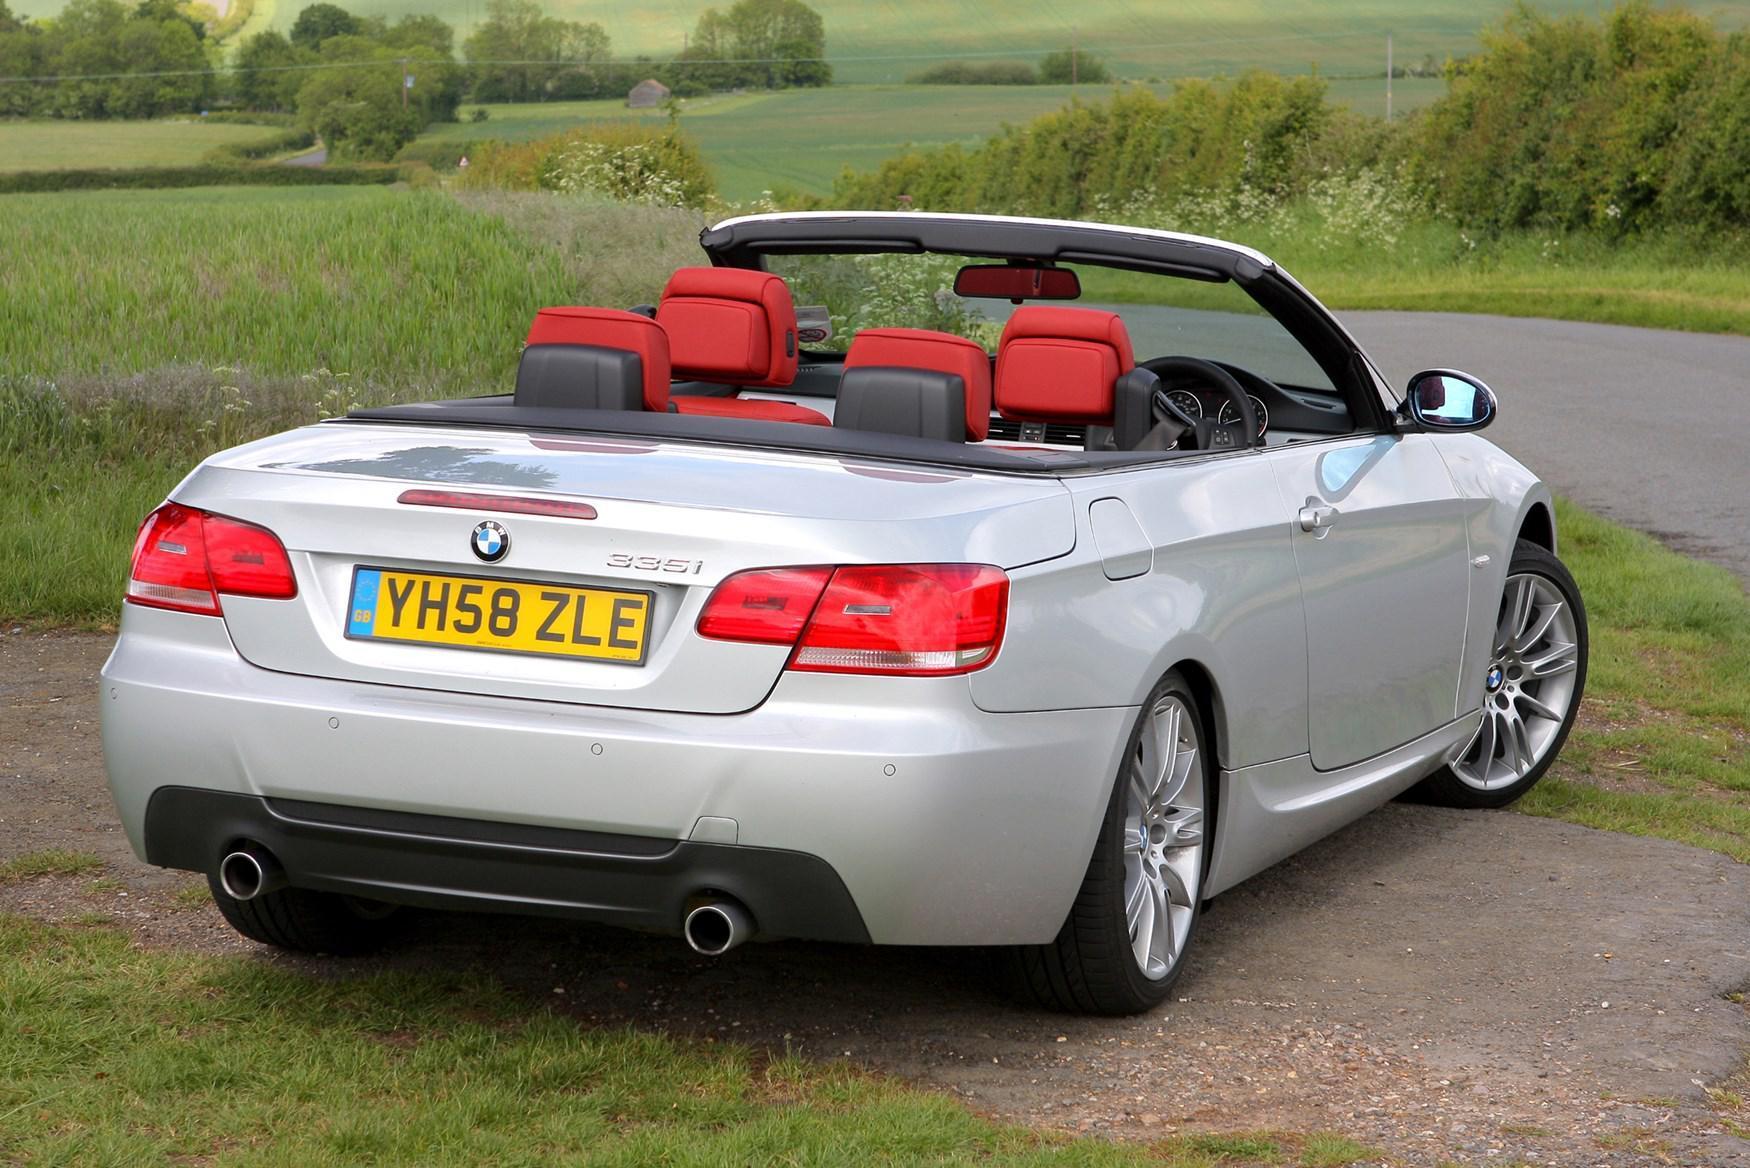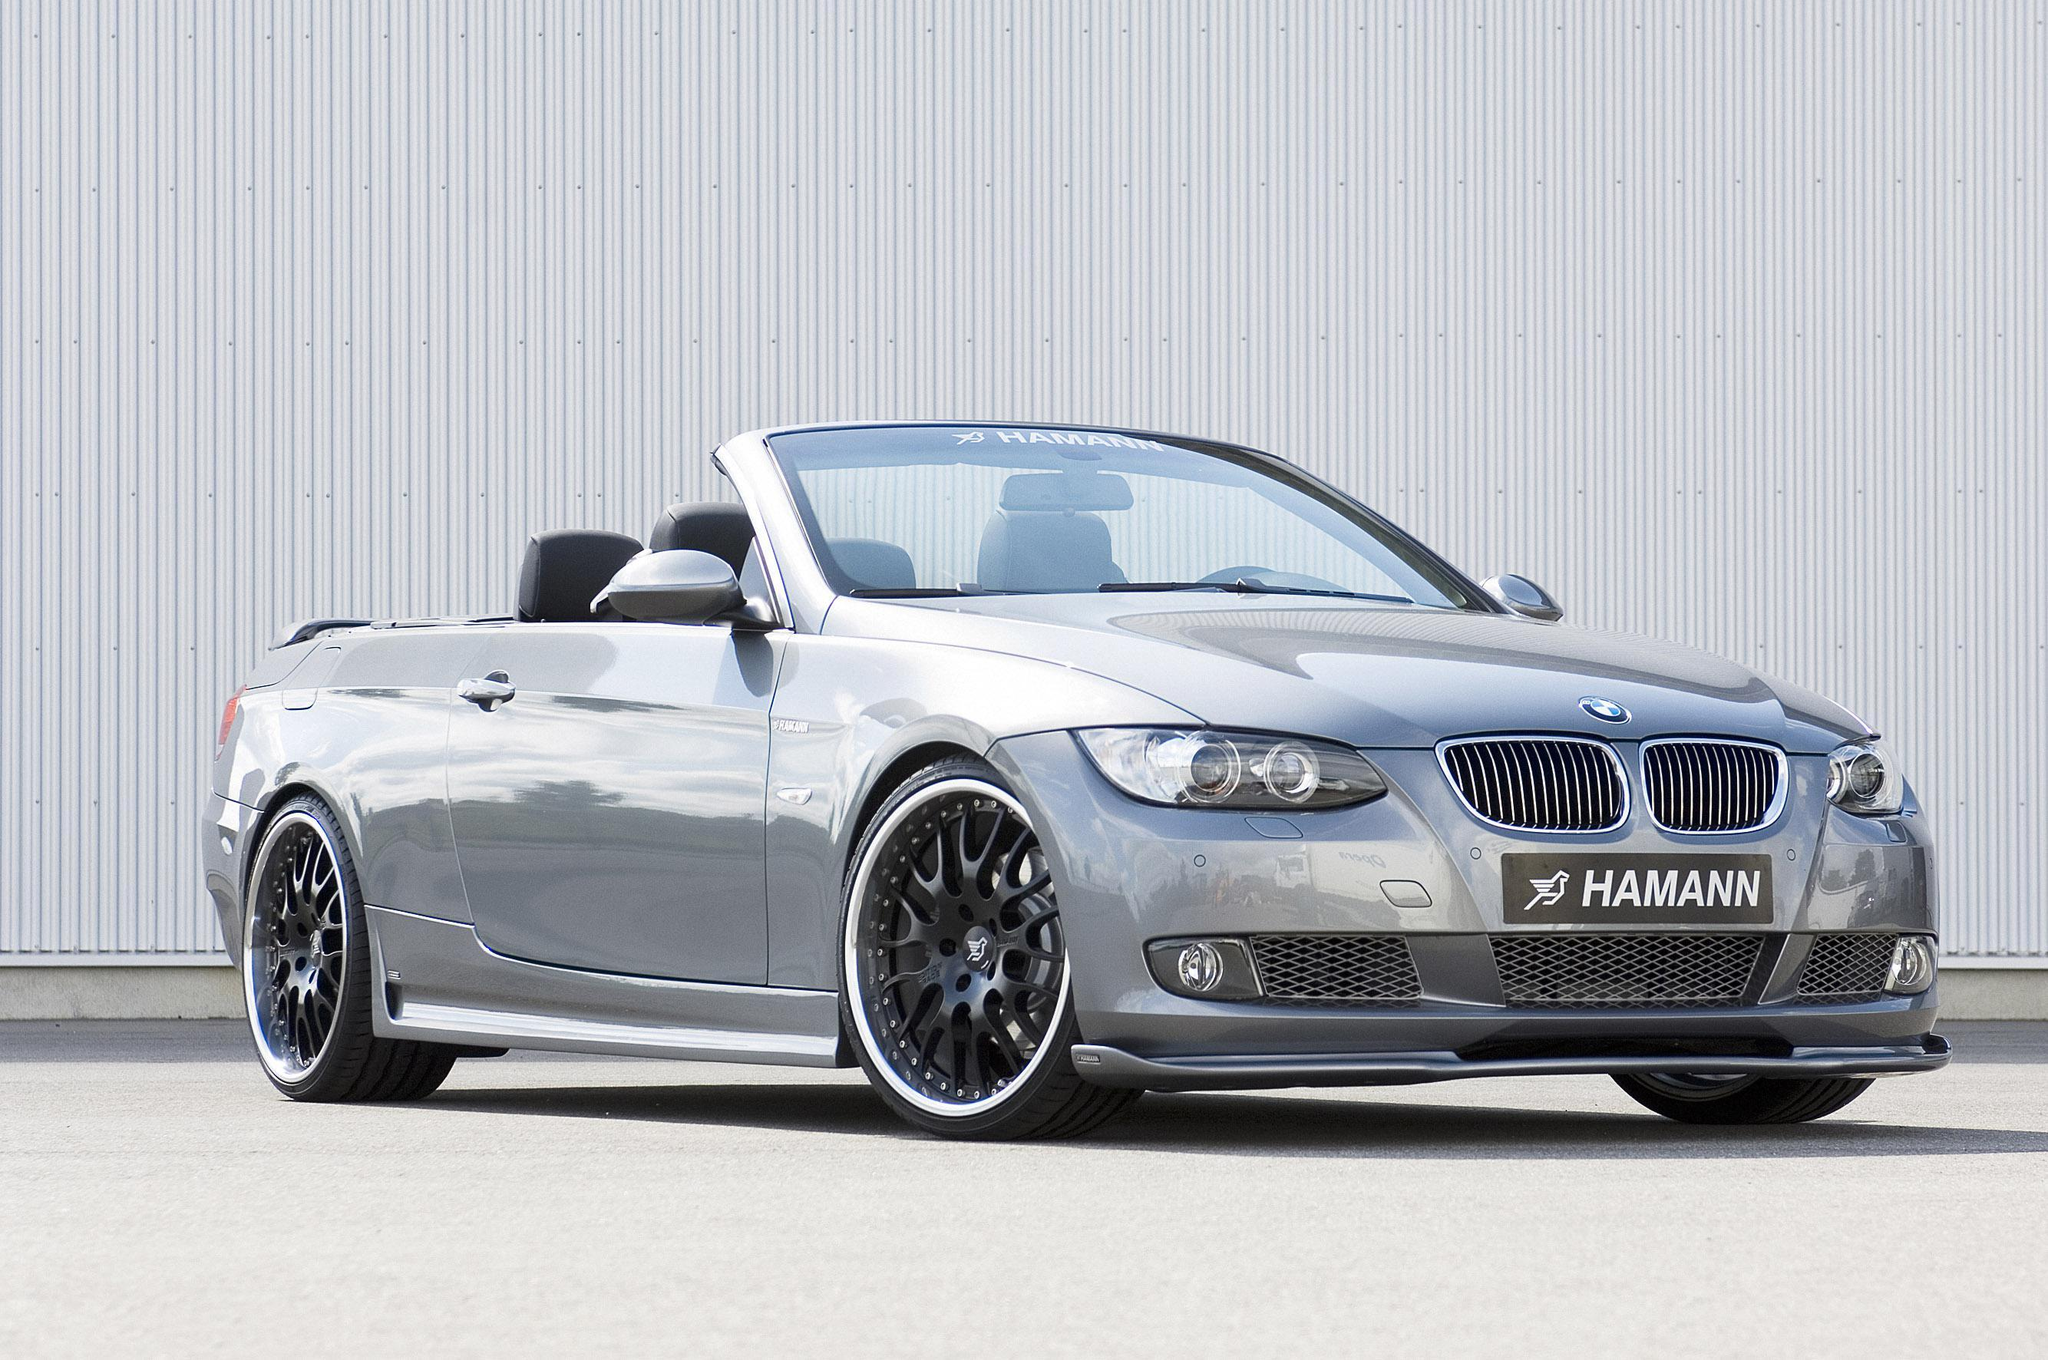The first image is the image on the left, the second image is the image on the right. Considering the images on both sides, is "An image has a blue convertible sports car." valid? Answer yes or no. No. The first image is the image on the left, the second image is the image on the right. Given the left and right images, does the statement "One convertible faces away from the camera, and the other is silver and facing rightward." hold true? Answer yes or no. Yes. 